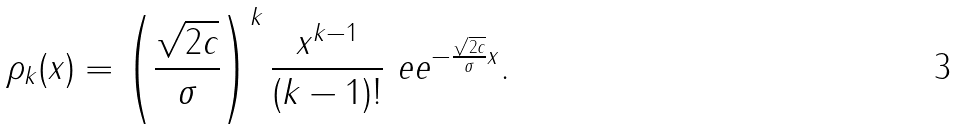<formula> <loc_0><loc_0><loc_500><loc_500>\rho _ { k } ( x ) = \left ( \frac { \sqrt { 2 c } } { \sigma } \right ) ^ { k } \frac { x ^ { k - 1 } } { ( k - 1 ) ! } \ e e ^ { - \frac { \sqrt { 2 c } } { \sigma } x } .</formula> 